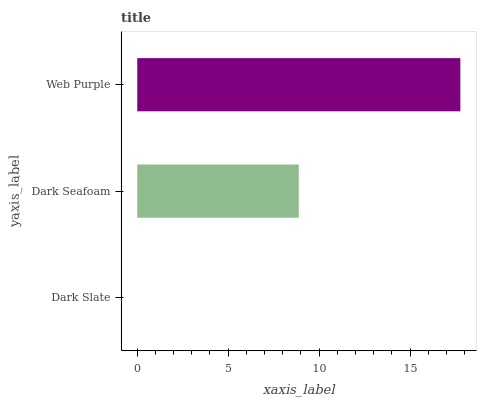Is Dark Slate the minimum?
Answer yes or no. Yes. Is Web Purple the maximum?
Answer yes or no. Yes. Is Dark Seafoam the minimum?
Answer yes or no. No. Is Dark Seafoam the maximum?
Answer yes or no. No. Is Dark Seafoam greater than Dark Slate?
Answer yes or no. Yes. Is Dark Slate less than Dark Seafoam?
Answer yes or no. Yes. Is Dark Slate greater than Dark Seafoam?
Answer yes or no. No. Is Dark Seafoam less than Dark Slate?
Answer yes or no. No. Is Dark Seafoam the high median?
Answer yes or no. Yes. Is Dark Seafoam the low median?
Answer yes or no. Yes. Is Web Purple the high median?
Answer yes or no. No. Is Dark Slate the low median?
Answer yes or no. No. 